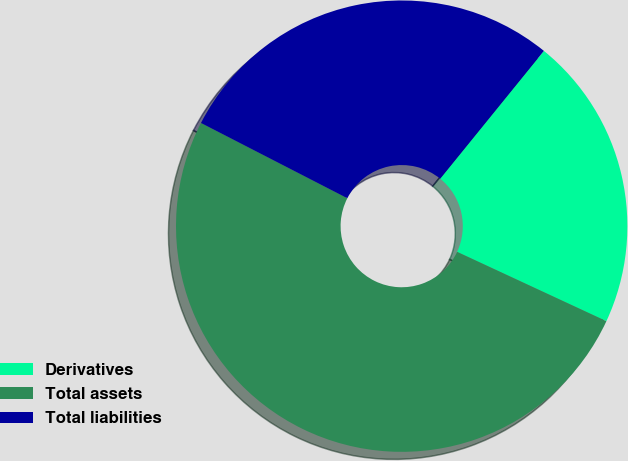Convert chart. <chart><loc_0><loc_0><loc_500><loc_500><pie_chart><fcel>Derivatives<fcel>Total assets<fcel>Total liabilities<nl><fcel>21.07%<fcel>50.64%<fcel>28.29%<nl></chart> 